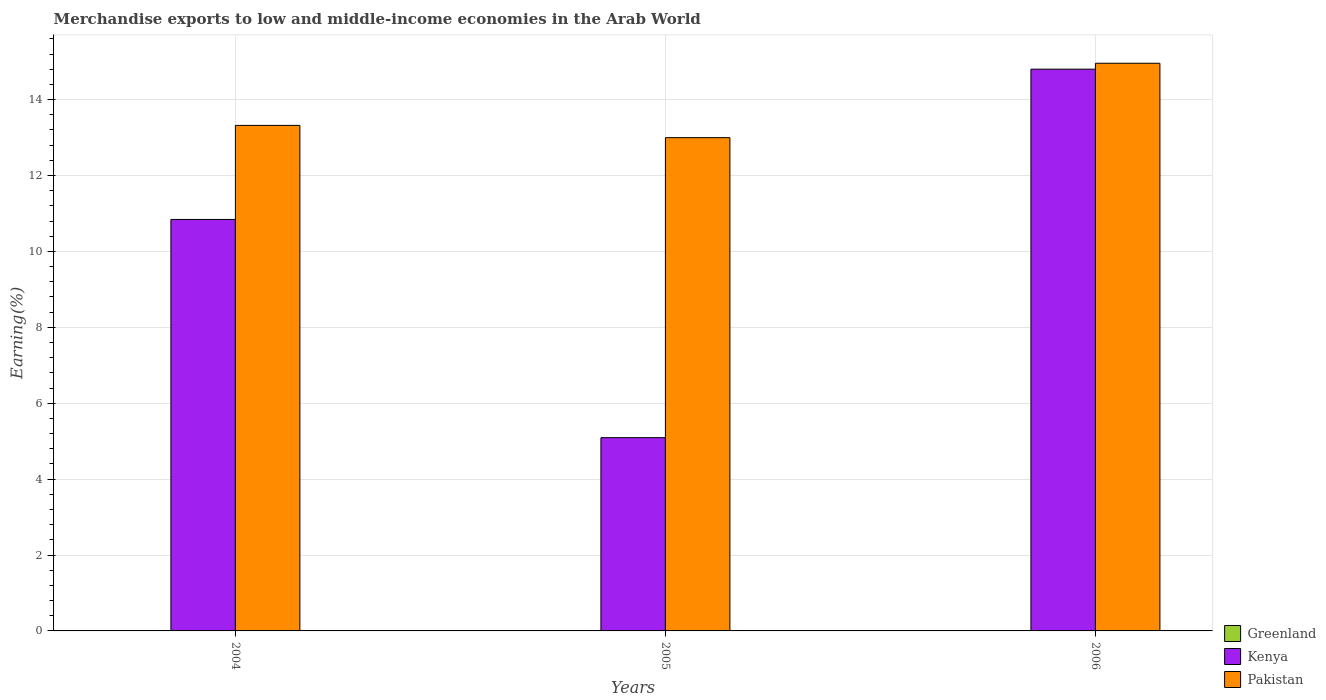How many different coloured bars are there?
Keep it short and to the point. 3. How many groups of bars are there?
Provide a succinct answer. 3. How many bars are there on the 1st tick from the right?
Provide a succinct answer. 3. What is the label of the 3rd group of bars from the left?
Ensure brevity in your answer.  2006. What is the percentage of amount earned from merchandise exports in Kenya in 2006?
Give a very brief answer. 14.8. Across all years, what is the maximum percentage of amount earned from merchandise exports in Kenya?
Give a very brief answer. 14.8. Across all years, what is the minimum percentage of amount earned from merchandise exports in Kenya?
Offer a very short reply. 5.09. In which year was the percentage of amount earned from merchandise exports in Greenland maximum?
Offer a very short reply. 2005. What is the total percentage of amount earned from merchandise exports in Kenya in the graph?
Your answer should be compact. 30.74. What is the difference between the percentage of amount earned from merchandise exports in Pakistan in 2004 and that in 2005?
Ensure brevity in your answer.  0.32. What is the difference between the percentage of amount earned from merchandise exports in Greenland in 2005 and the percentage of amount earned from merchandise exports in Kenya in 2004?
Offer a terse response. -10.84. What is the average percentage of amount earned from merchandise exports in Greenland per year?
Provide a succinct answer. 0. In the year 2006, what is the difference between the percentage of amount earned from merchandise exports in Pakistan and percentage of amount earned from merchandise exports in Kenya?
Your answer should be very brief. 0.16. What is the ratio of the percentage of amount earned from merchandise exports in Greenland in 2005 to that in 2006?
Your response must be concise. 1.24. What is the difference between the highest and the second highest percentage of amount earned from merchandise exports in Kenya?
Make the answer very short. 3.96. What is the difference between the highest and the lowest percentage of amount earned from merchandise exports in Kenya?
Offer a terse response. 9.71. In how many years, is the percentage of amount earned from merchandise exports in Kenya greater than the average percentage of amount earned from merchandise exports in Kenya taken over all years?
Offer a terse response. 2. Is the sum of the percentage of amount earned from merchandise exports in Greenland in 2005 and 2006 greater than the maximum percentage of amount earned from merchandise exports in Pakistan across all years?
Make the answer very short. No. What does the 3rd bar from the left in 2005 represents?
Your answer should be very brief. Pakistan. What does the 3rd bar from the right in 2005 represents?
Provide a short and direct response. Greenland. How many years are there in the graph?
Offer a terse response. 3. What is the difference between two consecutive major ticks on the Y-axis?
Offer a terse response. 2. Does the graph contain grids?
Offer a terse response. Yes. How many legend labels are there?
Keep it short and to the point. 3. What is the title of the graph?
Ensure brevity in your answer.  Merchandise exports to low and middle-income economies in the Arab World. Does "Iran" appear as one of the legend labels in the graph?
Provide a succinct answer. No. What is the label or title of the Y-axis?
Make the answer very short. Earning(%). What is the Earning(%) in Greenland in 2004?
Keep it short and to the point. 2.789635339457349e-5. What is the Earning(%) in Kenya in 2004?
Offer a terse response. 10.84. What is the Earning(%) of Pakistan in 2004?
Your response must be concise. 13.32. What is the Earning(%) of Greenland in 2005?
Your answer should be very brief. 0. What is the Earning(%) in Kenya in 2005?
Provide a succinct answer. 5.09. What is the Earning(%) of Pakistan in 2005?
Offer a very short reply. 13. What is the Earning(%) in Greenland in 2006?
Your answer should be compact. 0. What is the Earning(%) of Kenya in 2006?
Offer a terse response. 14.8. What is the Earning(%) of Pakistan in 2006?
Provide a succinct answer. 14.96. Across all years, what is the maximum Earning(%) in Greenland?
Offer a very short reply. 0. Across all years, what is the maximum Earning(%) in Kenya?
Offer a very short reply. 14.8. Across all years, what is the maximum Earning(%) in Pakistan?
Provide a succinct answer. 14.96. Across all years, what is the minimum Earning(%) in Greenland?
Your response must be concise. 2.789635339457349e-5. Across all years, what is the minimum Earning(%) in Kenya?
Your response must be concise. 5.09. Across all years, what is the minimum Earning(%) in Pakistan?
Offer a very short reply. 13. What is the total Earning(%) in Greenland in the graph?
Ensure brevity in your answer.  0. What is the total Earning(%) of Kenya in the graph?
Give a very brief answer. 30.74. What is the total Earning(%) in Pakistan in the graph?
Provide a short and direct response. 41.28. What is the difference between the Earning(%) of Greenland in 2004 and that in 2005?
Your answer should be compact. -0. What is the difference between the Earning(%) in Kenya in 2004 and that in 2005?
Your response must be concise. 5.75. What is the difference between the Earning(%) of Pakistan in 2004 and that in 2005?
Offer a terse response. 0.32. What is the difference between the Earning(%) in Greenland in 2004 and that in 2006?
Ensure brevity in your answer.  -0. What is the difference between the Earning(%) in Kenya in 2004 and that in 2006?
Your answer should be compact. -3.96. What is the difference between the Earning(%) of Pakistan in 2004 and that in 2006?
Ensure brevity in your answer.  -1.64. What is the difference between the Earning(%) of Greenland in 2005 and that in 2006?
Provide a short and direct response. 0. What is the difference between the Earning(%) in Kenya in 2005 and that in 2006?
Ensure brevity in your answer.  -9.71. What is the difference between the Earning(%) of Pakistan in 2005 and that in 2006?
Ensure brevity in your answer.  -1.96. What is the difference between the Earning(%) in Greenland in 2004 and the Earning(%) in Kenya in 2005?
Your answer should be very brief. -5.09. What is the difference between the Earning(%) in Greenland in 2004 and the Earning(%) in Pakistan in 2005?
Provide a succinct answer. -13. What is the difference between the Earning(%) of Kenya in 2004 and the Earning(%) of Pakistan in 2005?
Give a very brief answer. -2.15. What is the difference between the Earning(%) of Greenland in 2004 and the Earning(%) of Kenya in 2006?
Give a very brief answer. -14.8. What is the difference between the Earning(%) of Greenland in 2004 and the Earning(%) of Pakistan in 2006?
Give a very brief answer. -14.96. What is the difference between the Earning(%) in Kenya in 2004 and the Earning(%) in Pakistan in 2006?
Your response must be concise. -4.12. What is the difference between the Earning(%) in Greenland in 2005 and the Earning(%) in Kenya in 2006?
Keep it short and to the point. -14.8. What is the difference between the Earning(%) in Greenland in 2005 and the Earning(%) in Pakistan in 2006?
Offer a very short reply. -14.96. What is the difference between the Earning(%) of Kenya in 2005 and the Earning(%) of Pakistan in 2006?
Make the answer very short. -9.87. What is the average Earning(%) in Kenya per year?
Your answer should be compact. 10.25. What is the average Earning(%) of Pakistan per year?
Your response must be concise. 13.76. In the year 2004, what is the difference between the Earning(%) of Greenland and Earning(%) of Kenya?
Your answer should be compact. -10.84. In the year 2004, what is the difference between the Earning(%) in Greenland and Earning(%) in Pakistan?
Provide a succinct answer. -13.32. In the year 2004, what is the difference between the Earning(%) in Kenya and Earning(%) in Pakistan?
Your answer should be compact. -2.48. In the year 2005, what is the difference between the Earning(%) in Greenland and Earning(%) in Kenya?
Offer a very short reply. -5.09. In the year 2005, what is the difference between the Earning(%) of Greenland and Earning(%) of Pakistan?
Make the answer very short. -13. In the year 2005, what is the difference between the Earning(%) of Kenya and Earning(%) of Pakistan?
Make the answer very short. -7.9. In the year 2006, what is the difference between the Earning(%) of Greenland and Earning(%) of Kenya?
Ensure brevity in your answer.  -14.8. In the year 2006, what is the difference between the Earning(%) in Greenland and Earning(%) in Pakistan?
Give a very brief answer. -14.96. In the year 2006, what is the difference between the Earning(%) of Kenya and Earning(%) of Pakistan?
Provide a succinct answer. -0.16. What is the ratio of the Earning(%) of Greenland in 2004 to that in 2005?
Keep it short and to the point. 0.03. What is the ratio of the Earning(%) in Kenya in 2004 to that in 2005?
Offer a very short reply. 2.13. What is the ratio of the Earning(%) of Pakistan in 2004 to that in 2005?
Offer a very short reply. 1.02. What is the ratio of the Earning(%) of Greenland in 2004 to that in 2006?
Ensure brevity in your answer.  0.04. What is the ratio of the Earning(%) of Kenya in 2004 to that in 2006?
Your response must be concise. 0.73. What is the ratio of the Earning(%) of Pakistan in 2004 to that in 2006?
Keep it short and to the point. 0.89. What is the ratio of the Earning(%) in Greenland in 2005 to that in 2006?
Provide a succinct answer. 1.24. What is the ratio of the Earning(%) of Kenya in 2005 to that in 2006?
Make the answer very short. 0.34. What is the ratio of the Earning(%) in Pakistan in 2005 to that in 2006?
Your response must be concise. 0.87. What is the difference between the highest and the second highest Earning(%) in Greenland?
Provide a short and direct response. 0. What is the difference between the highest and the second highest Earning(%) in Kenya?
Ensure brevity in your answer.  3.96. What is the difference between the highest and the second highest Earning(%) in Pakistan?
Offer a very short reply. 1.64. What is the difference between the highest and the lowest Earning(%) in Greenland?
Offer a terse response. 0. What is the difference between the highest and the lowest Earning(%) in Kenya?
Keep it short and to the point. 9.71. What is the difference between the highest and the lowest Earning(%) in Pakistan?
Your answer should be very brief. 1.96. 